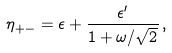<formula> <loc_0><loc_0><loc_500><loc_500>\eta _ { + - } = \epsilon + \frac { \epsilon ^ { \prime } } { 1 + \omega / \sqrt { 2 } } \, ,</formula> 